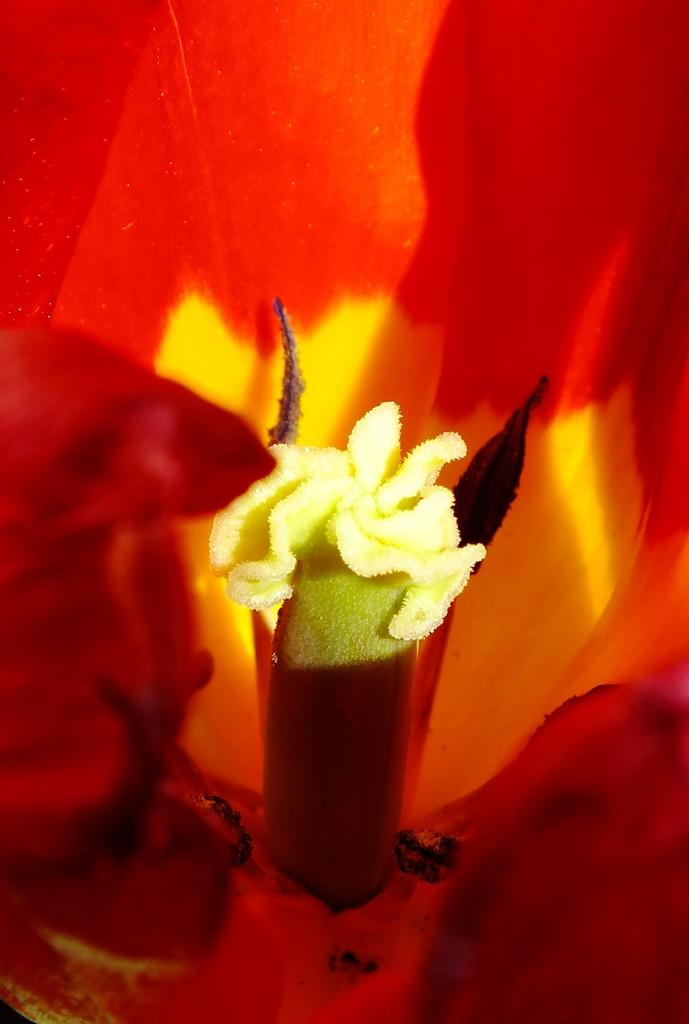What type of plant can be seen in the image? There is a flower in the image. How many sheep are in the flock that is visible in the image? There is no flock or sheep present in the image; it features a flower. What type of sea creature can be seen swimming in the image? There is no sea creature present in the image; it features a flower. 